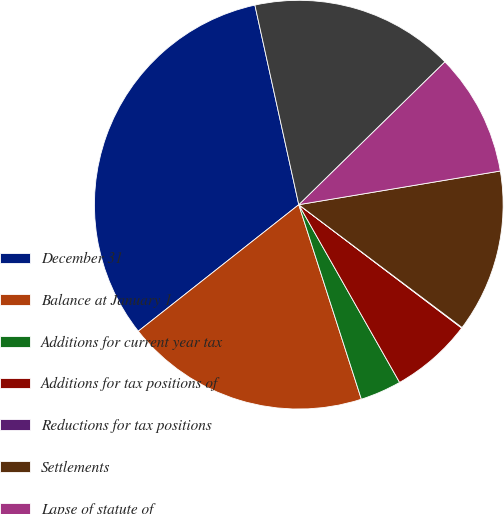Convert chart to OTSL. <chart><loc_0><loc_0><loc_500><loc_500><pie_chart><fcel>December 31<fcel>Balance at January 1<fcel>Additions for current year tax<fcel>Additions for tax positions of<fcel>Reductions for tax positions<fcel>Settlements<fcel>Lapse of statute of<fcel>Balance at December 31<nl><fcel>32.18%<fcel>19.33%<fcel>3.26%<fcel>6.47%<fcel>0.05%<fcel>12.9%<fcel>9.69%<fcel>16.12%<nl></chart> 